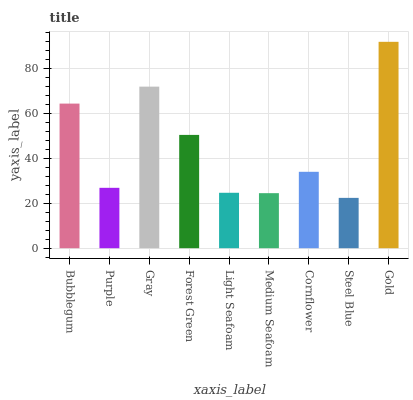Is Steel Blue the minimum?
Answer yes or no. Yes. Is Gold the maximum?
Answer yes or no. Yes. Is Purple the minimum?
Answer yes or no. No. Is Purple the maximum?
Answer yes or no. No. Is Bubblegum greater than Purple?
Answer yes or no. Yes. Is Purple less than Bubblegum?
Answer yes or no. Yes. Is Purple greater than Bubblegum?
Answer yes or no. No. Is Bubblegum less than Purple?
Answer yes or no. No. Is Cornflower the high median?
Answer yes or no. Yes. Is Cornflower the low median?
Answer yes or no. Yes. Is Forest Green the high median?
Answer yes or no. No. Is Gold the low median?
Answer yes or no. No. 